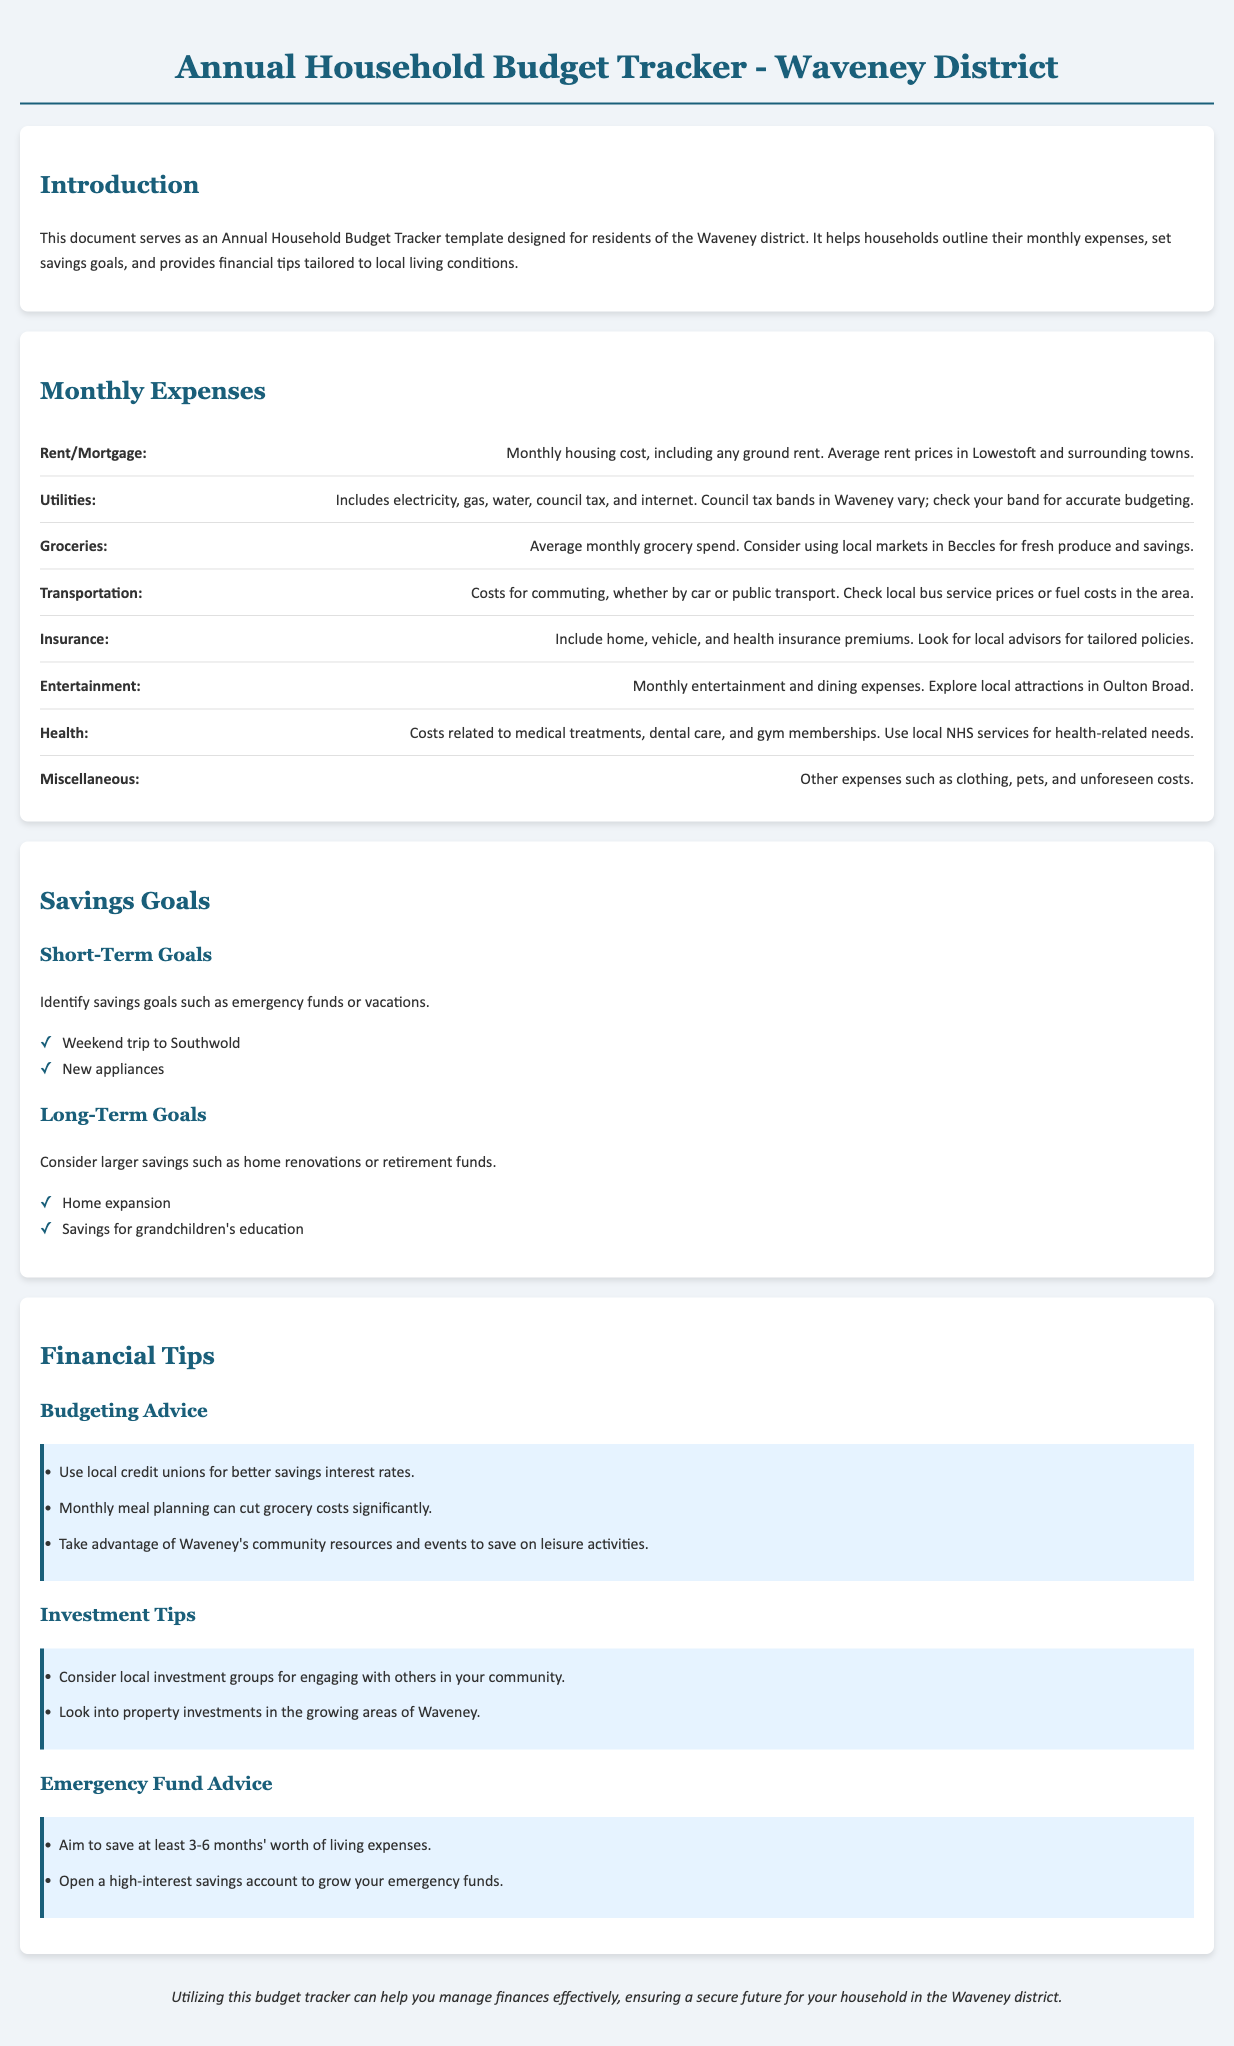What is the purpose of the document? The purpose of the document is to serve as an Annual Household Budget Tracker template designed for residents of the Waveney district.
Answer: Annual Household Budget Tracker template What expenses are included under Utilities? Utilities expenses include electricity, gas, water, council tax, and internet.
Answer: Electricity, gas, water, council tax, internet What is a recommended short-term savings goal? A recommended short-term savings goal is a weekend trip to Southwold.
Answer: Weekend trip to Southwold How many months' worth of living expenses should an emergency fund aim to save? The emergency fund should aim to save at least 3-6 months' worth of living expenses.
Answer: 3-6 months What is a suggested way to cut grocery costs? A suggested way to cut grocery costs is through monthly meal planning.
Answer: Monthly meal planning What are two insurance types mentioned in the document? The document mentions home and vehicle insurance premiums.
Answer: Home, vehicle What local resource can help with better savings interest rates? Local credit unions can help with better savings interest rates.
Answer: Local credit unions Which local market is mentioned for fresh produce? The local market mentioned for fresh produce is in Beccles.
Answer: Beccles 